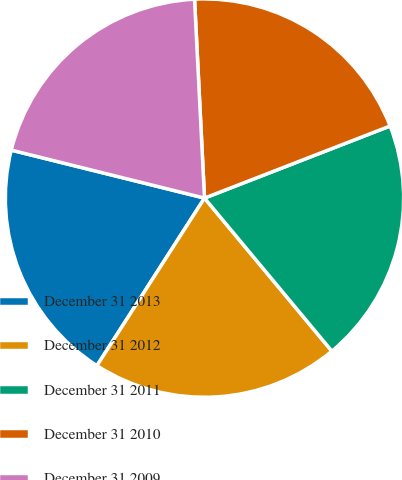<chart> <loc_0><loc_0><loc_500><loc_500><pie_chart><fcel>December 31 2013<fcel>December 31 2012<fcel>December 31 2011<fcel>December 31 2010<fcel>December 31 2009<nl><fcel>19.79%<fcel>20.13%<fcel>19.85%<fcel>19.9%<fcel>20.33%<nl></chart> 